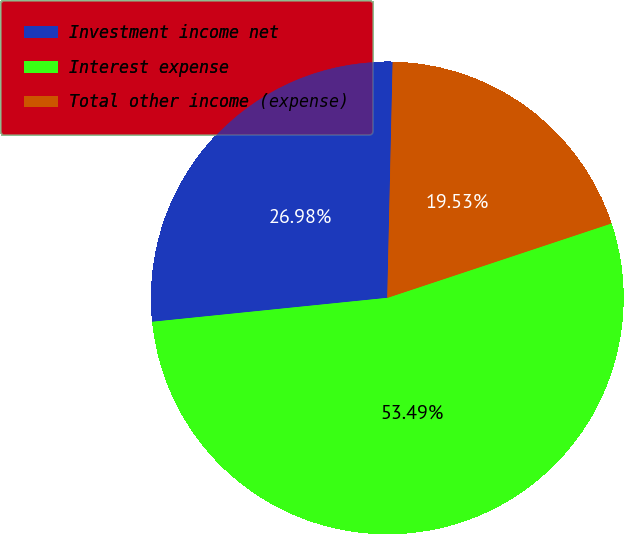<chart> <loc_0><loc_0><loc_500><loc_500><pie_chart><fcel>Investment income net<fcel>Interest expense<fcel>Total other income (expense)<nl><fcel>26.98%<fcel>53.49%<fcel>19.53%<nl></chart> 